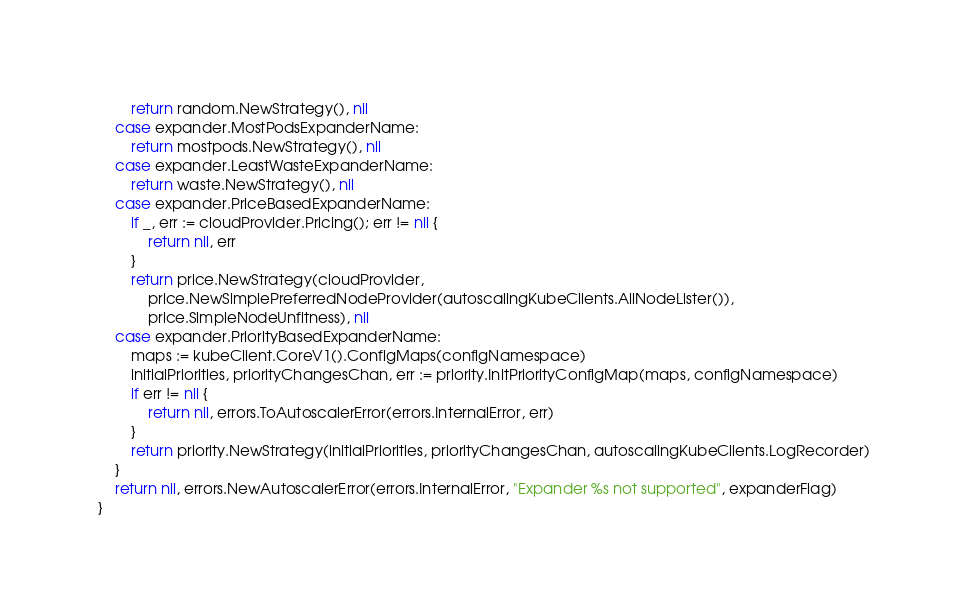<code> <loc_0><loc_0><loc_500><loc_500><_Go_>		return random.NewStrategy(), nil
	case expander.MostPodsExpanderName:
		return mostpods.NewStrategy(), nil
	case expander.LeastWasteExpanderName:
		return waste.NewStrategy(), nil
	case expander.PriceBasedExpanderName:
		if _, err := cloudProvider.Pricing(); err != nil {
			return nil, err
		}
		return price.NewStrategy(cloudProvider,
			price.NewSimplePreferredNodeProvider(autoscalingKubeClients.AllNodeLister()),
			price.SimpleNodeUnfitness), nil
	case expander.PriorityBasedExpanderName:
		maps := kubeClient.CoreV1().ConfigMaps(configNamespace)
		initialPriorities, priorityChangesChan, err := priority.InitPriorityConfigMap(maps, configNamespace)
		if err != nil {
			return nil, errors.ToAutoscalerError(errors.InternalError, err)
		}
		return priority.NewStrategy(initialPriorities, priorityChangesChan, autoscalingKubeClients.LogRecorder)
	}
	return nil, errors.NewAutoscalerError(errors.InternalError, "Expander %s not supported", expanderFlag)
}
</code> 